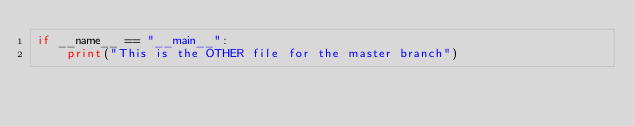<code> <loc_0><loc_0><loc_500><loc_500><_Python_>if __name__ == "__main__":
    print("This is the OTHER file for the master branch")</code> 